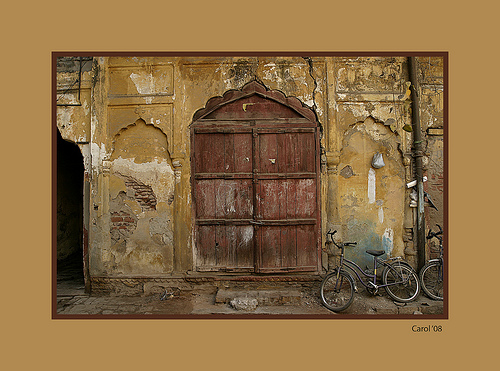Please provide a short description for this region: [0.11, 0.44, 0.18, 0.68]. The narrow alleyway at these coordinates offers a glimpse into a shaded passageway beside the aging walls. 